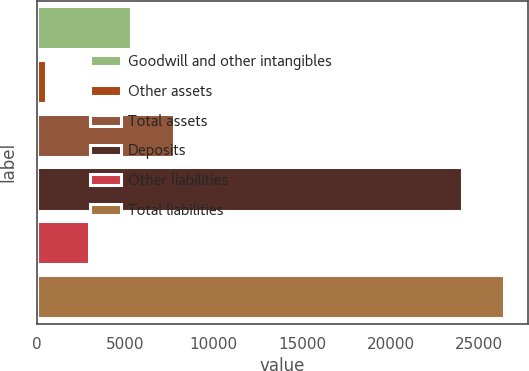<chart> <loc_0><loc_0><loc_500><loc_500><bar_chart><fcel>Goodwill and other intangibles<fcel>Other assets<fcel>Total assets<fcel>Deposits<fcel>Other liabilities<fcel>Total liabilities<nl><fcel>5349.2<fcel>547<fcel>7750.3<fcel>24011<fcel>2948.1<fcel>26412.1<nl></chart> 